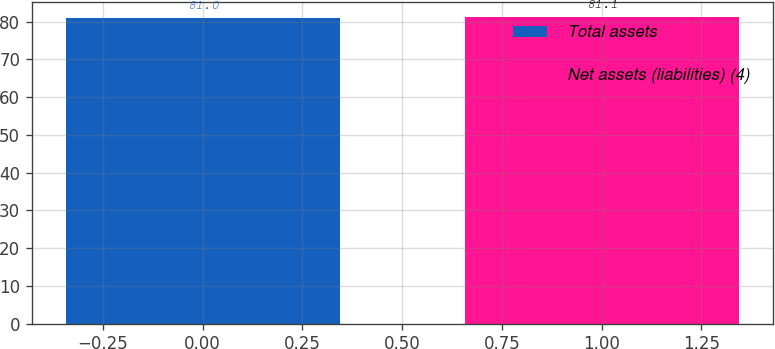<chart> <loc_0><loc_0><loc_500><loc_500><bar_chart><fcel>Total assets<fcel>Net assets (liabilities) (4)<nl><fcel>81<fcel>81.1<nl></chart> 